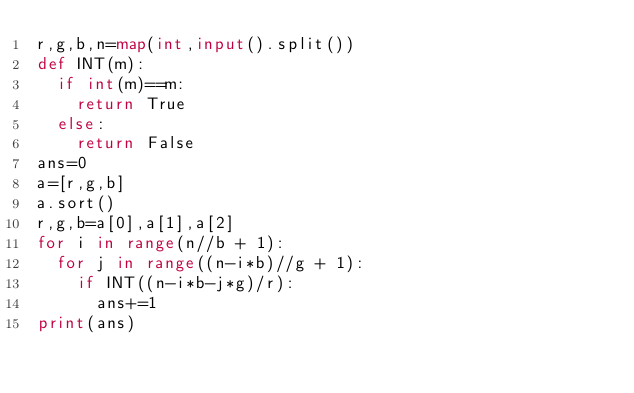<code> <loc_0><loc_0><loc_500><loc_500><_Python_>r,g,b,n=map(int,input().split())
def INT(m):
  if int(m)==m:
    return True
  else:
    return False
ans=0
a=[r,g,b]
a.sort()
r,g,b=a[0],a[1],a[2]
for i in range(n//b + 1):
  for j in range((n-i*b)//g + 1):
    if INT((n-i*b-j*g)/r):
      ans+=1
print(ans)</code> 